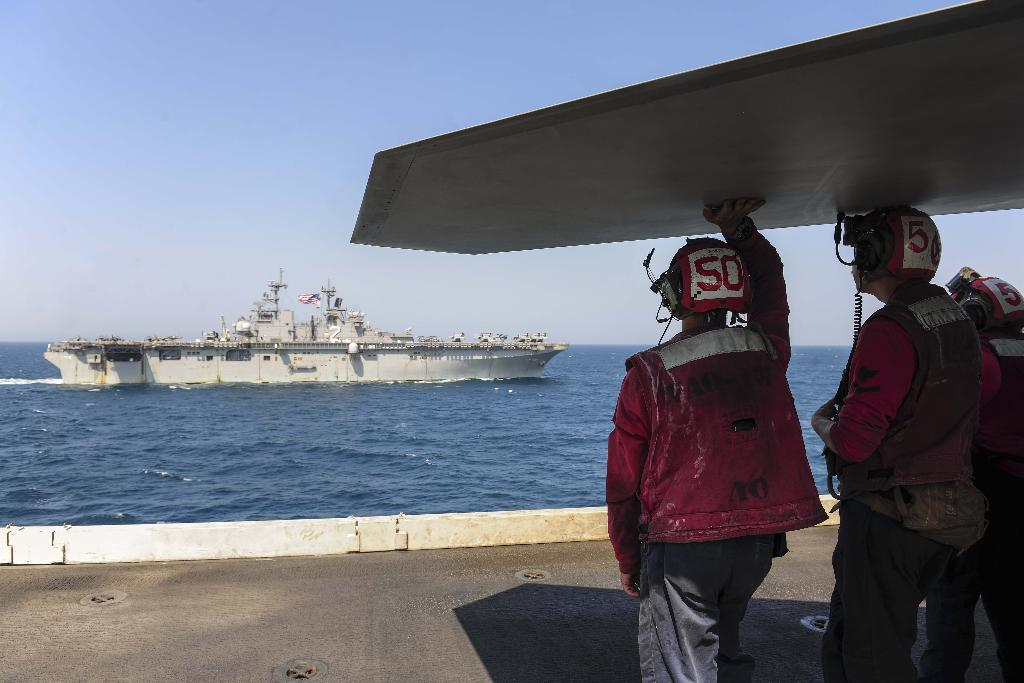<image>
Create a compact narrative representing the image presented. Two men with helmets on a ship with the number 50 on the helmets. 